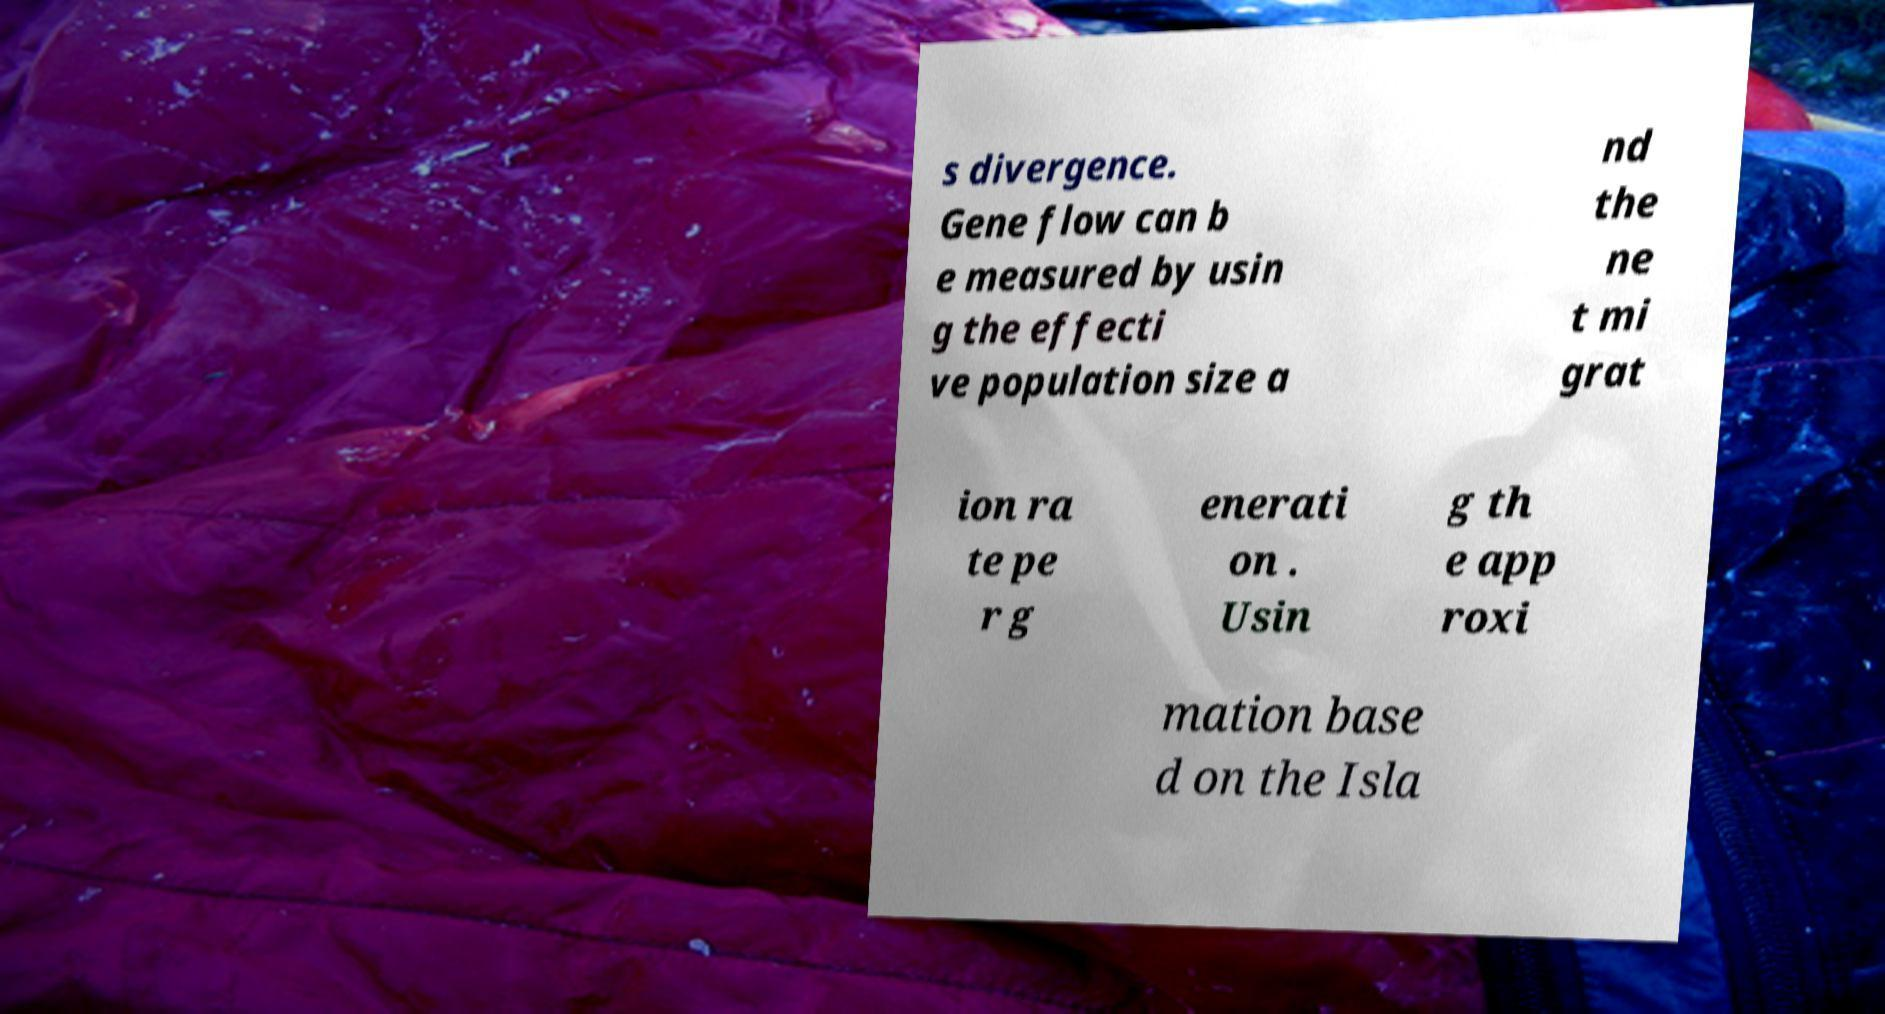There's text embedded in this image that I need extracted. Can you transcribe it verbatim? s divergence. Gene flow can b e measured by usin g the effecti ve population size a nd the ne t mi grat ion ra te pe r g enerati on . Usin g th e app roxi mation base d on the Isla 